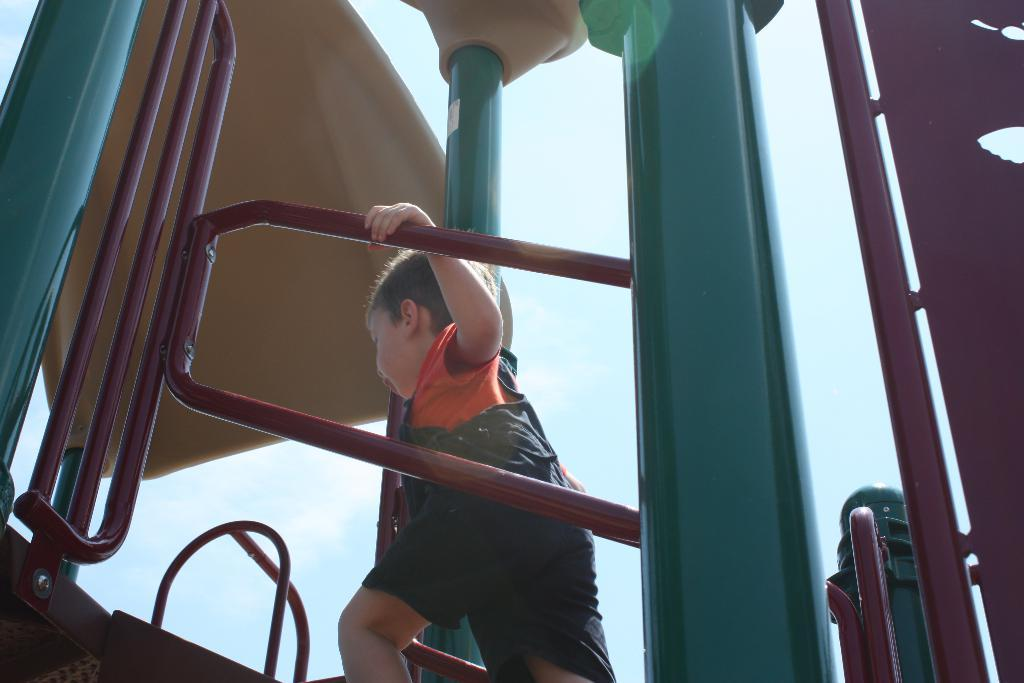Who is the main subject in the image? There is a boy in the image. What is the boy doing in the image? The boy is walking in the image. What is the boy holding onto while walking? The boy is holding a handrail in the image. What can be seen in the foreground of the image? There is a slider in the foreground of the image. What is visible at the top of the image? The sky is visible at the top of the image. What is the manager's condition regarding the boy's debt in the image? There is no mention of a manager or debt in the image; it only features a boy walking and holding a handrail. 